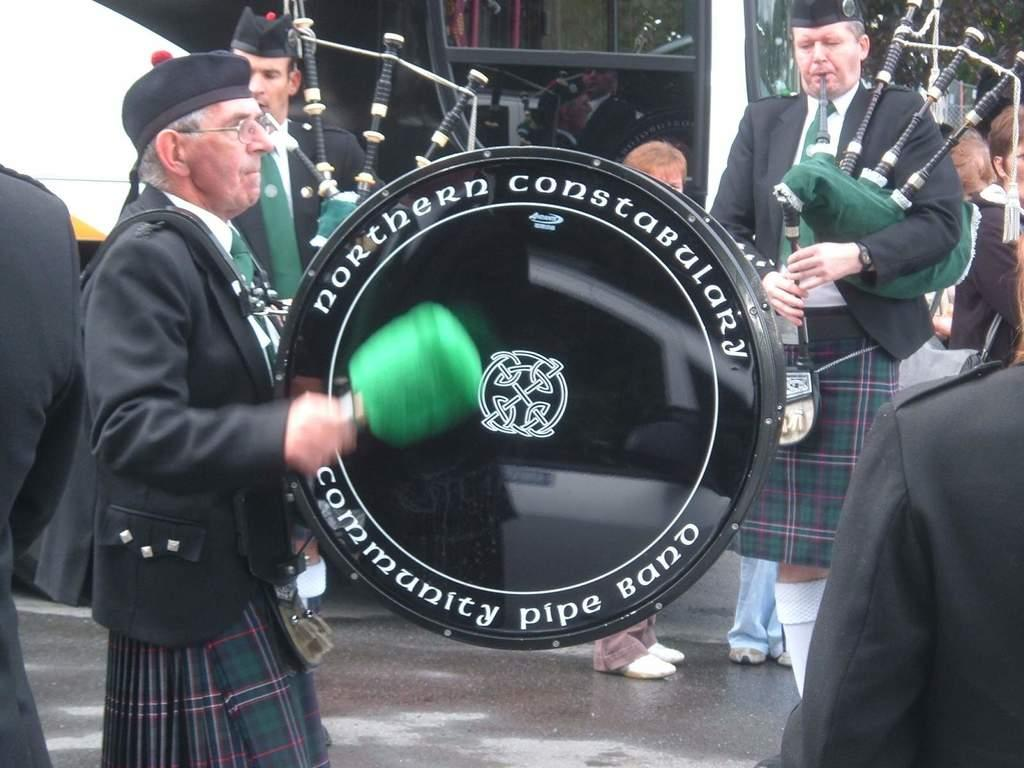What are the people in the image doing? The people in the image are playing musical instruments. What type of headwear are the people wearing? The people are wearing caps. What type of clothing are the people wearing? The people are wearing uniforms. What can be seen in the background of the image? There is a building visible in the background of the image. Where is the lunchroom located in the image? There is no mention of a lunchroom in the image; it features people playing musical instruments. What type of cake is being served in the image? There is no cake present in the image. 